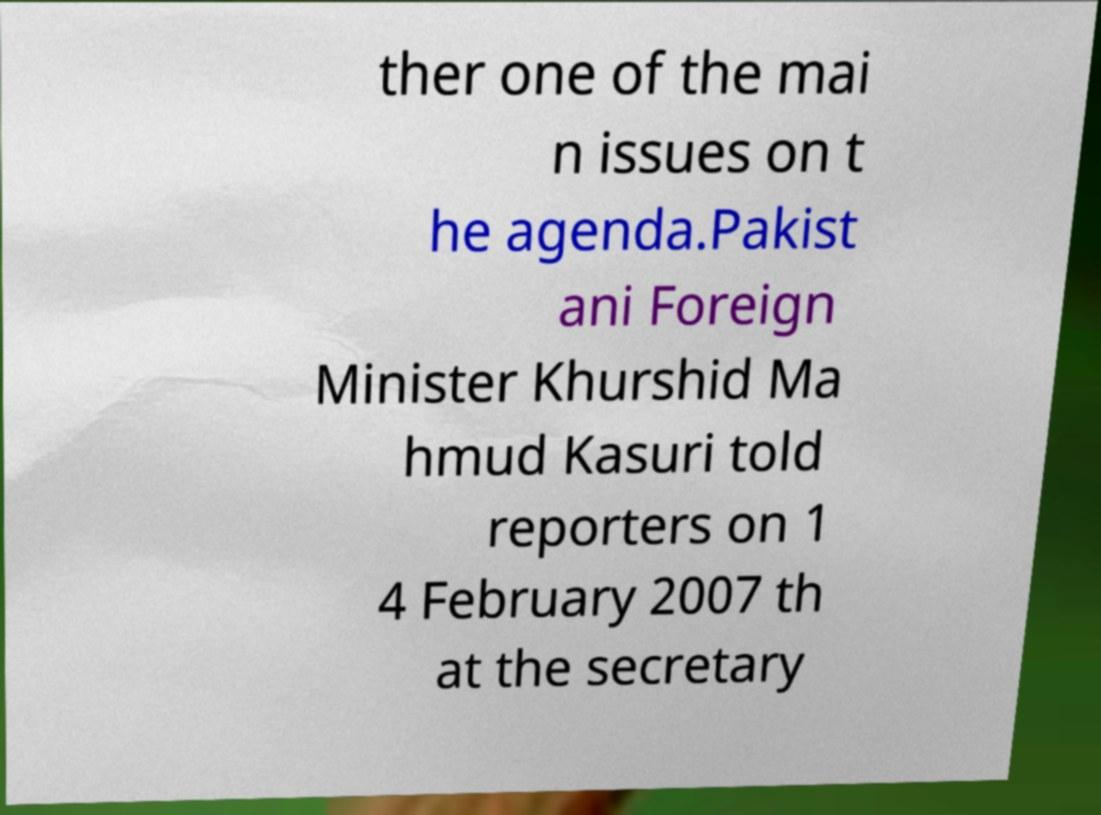Could you extract and type out the text from this image? ther one of the mai n issues on t he agenda.Pakist ani Foreign Minister Khurshid Ma hmud Kasuri told reporters on 1 4 February 2007 th at the secretary 